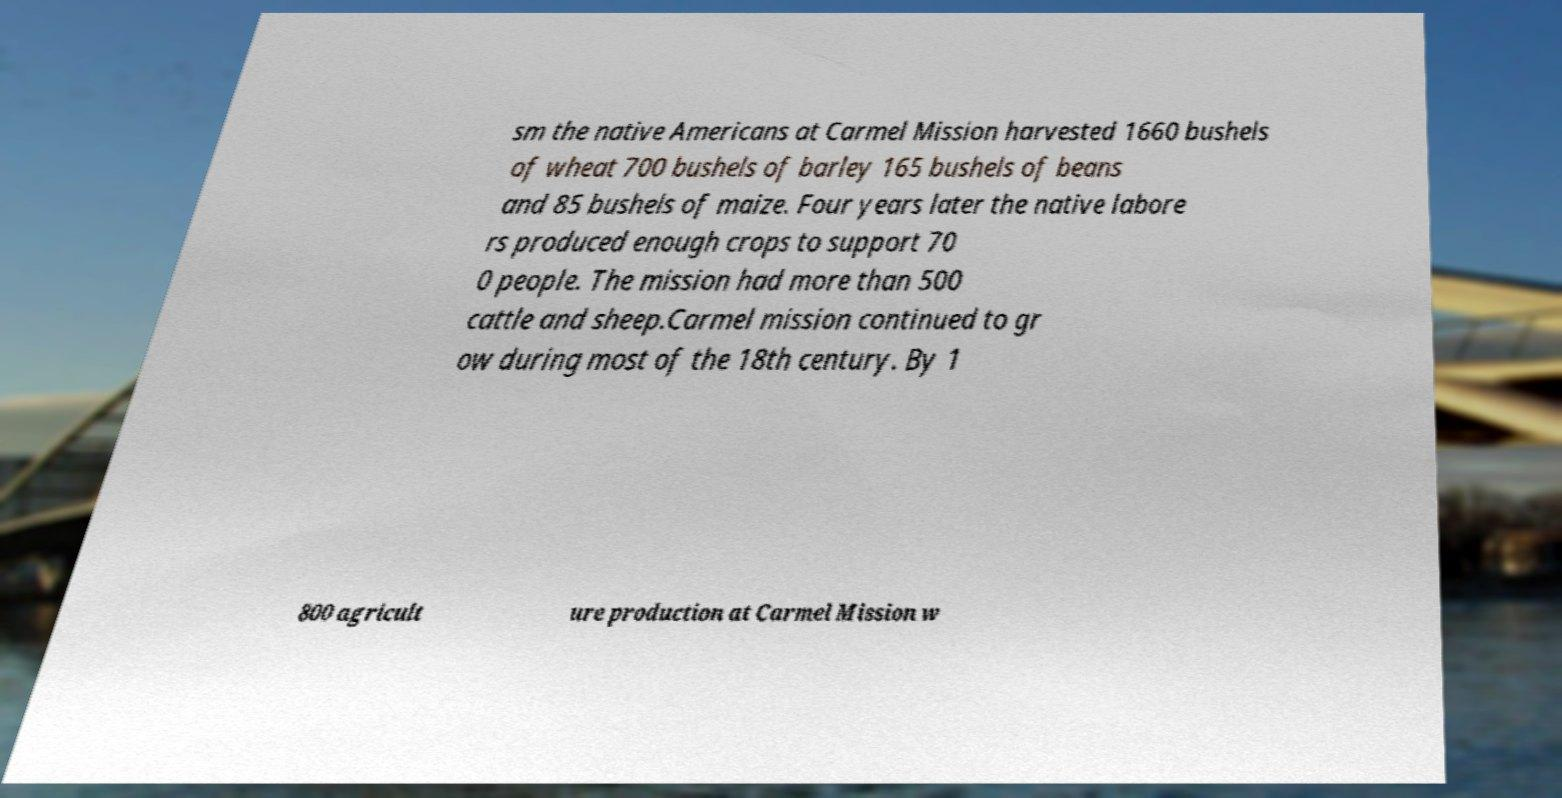Can you read and provide the text displayed in the image?This photo seems to have some interesting text. Can you extract and type it out for me? sm the native Americans at Carmel Mission harvested 1660 bushels of wheat 700 bushels of barley 165 bushels of beans and 85 bushels of maize. Four years later the native labore rs produced enough crops to support 70 0 people. The mission had more than 500 cattle and sheep.Carmel mission continued to gr ow during most of the 18th century. By 1 800 agricult ure production at Carmel Mission w 